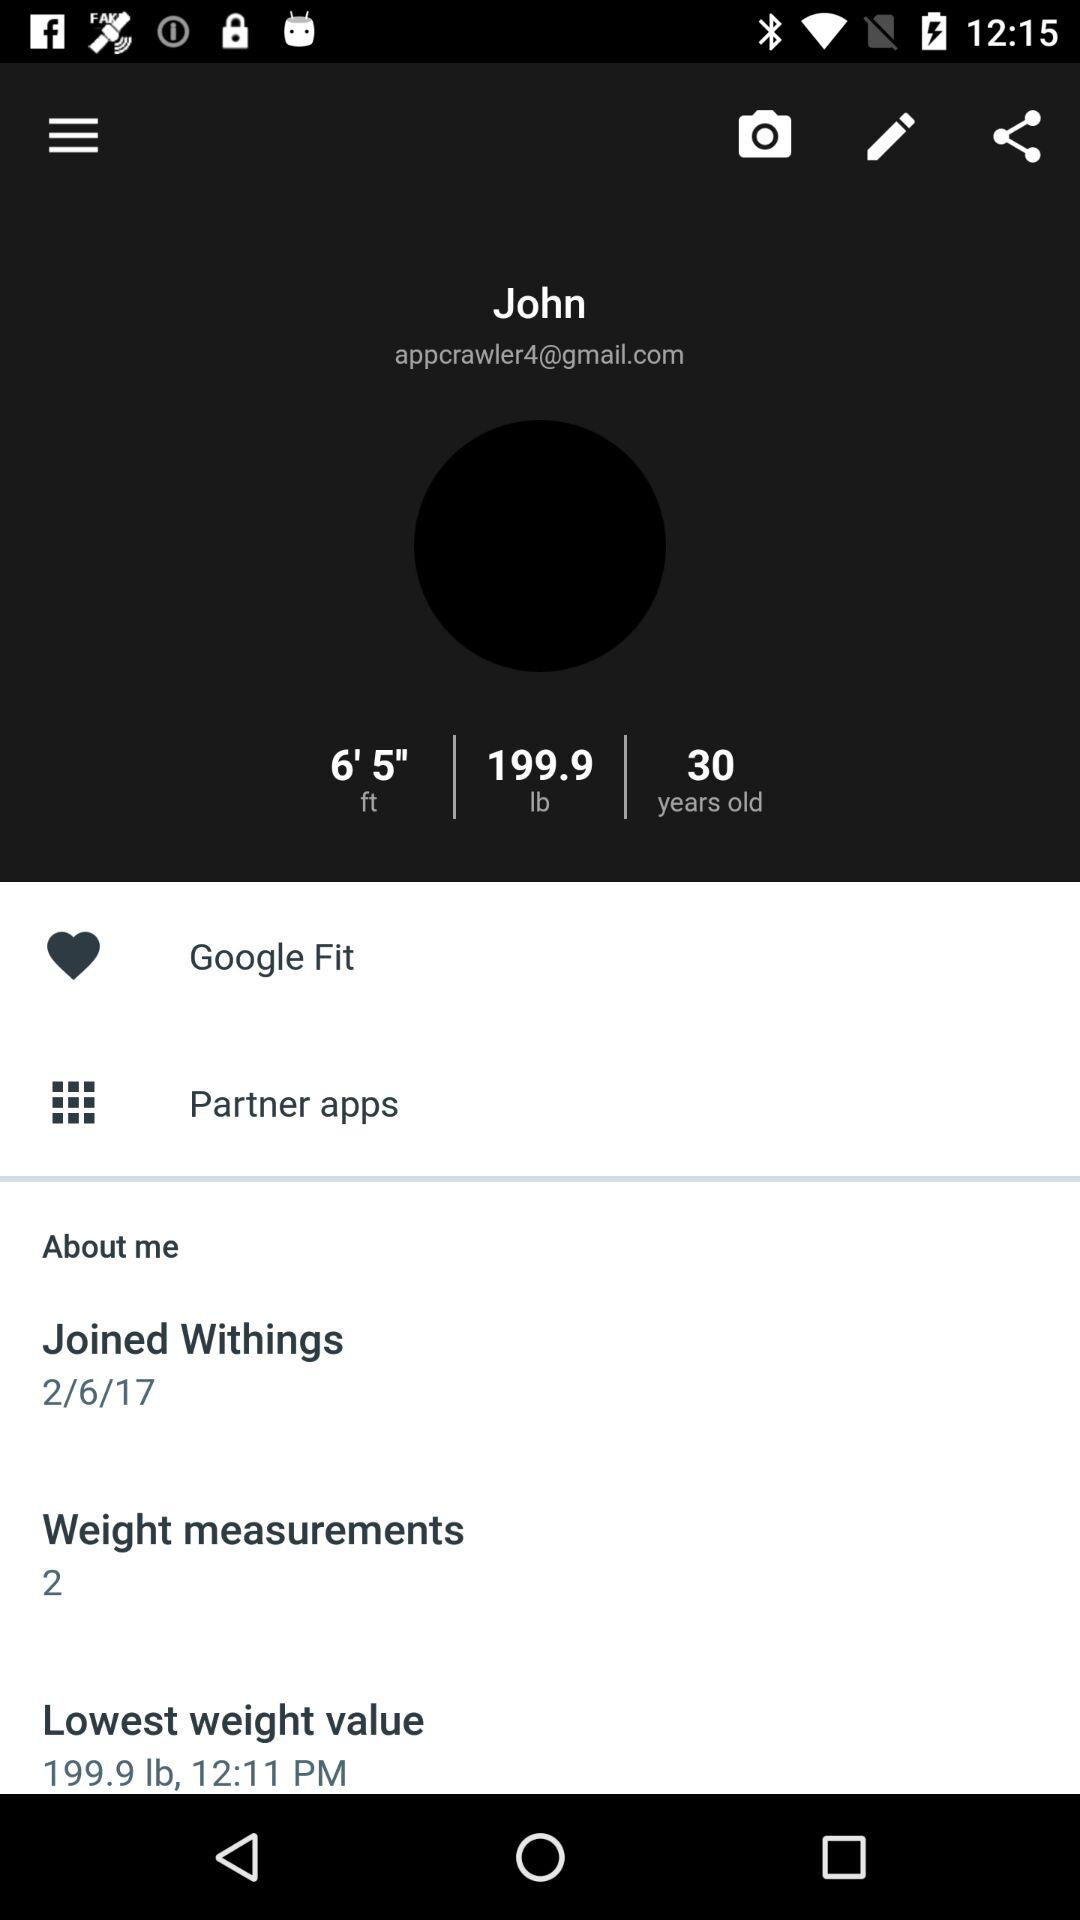What is the age of a user? The age of a user is 30 years old. 